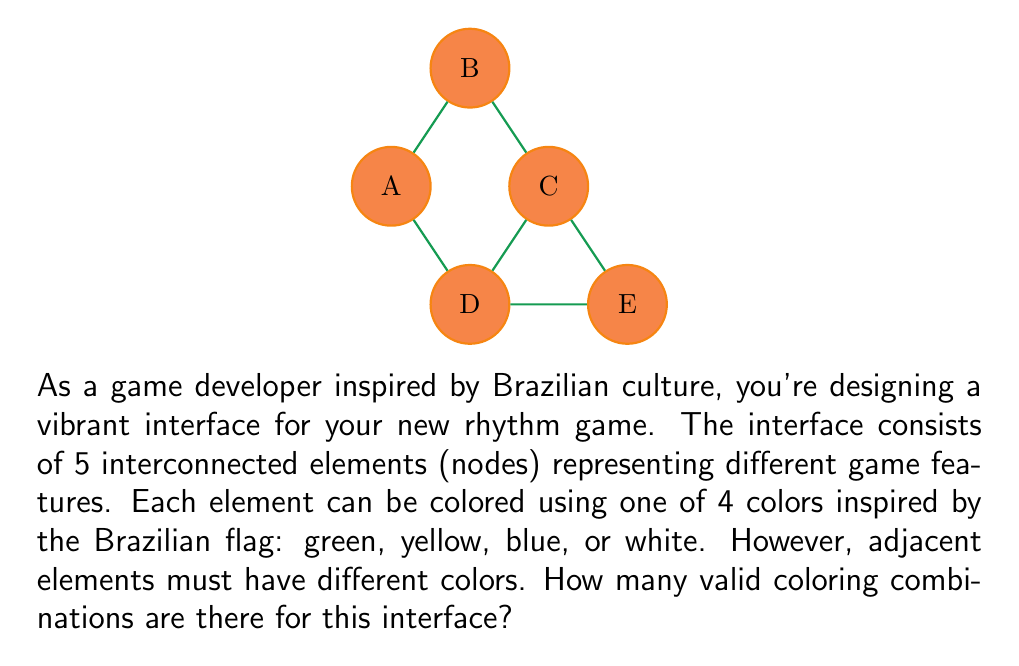Help me with this question. Let's approach this problem using graph coloring and the multiplication principle:

1) First, we need to recognize that this is a graph coloring problem where each node represents an interface element, and edges represent adjacency.

2) We'll use the chromatic polynomial to solve this. The chromatic polynomial $P(G,k)$ gives the number of ways to color a graph $G$ using $k$ colors.

3) For this graph, the chromatic polynomial is:

   $P(G,k) = k(k-1)^2(k-2)^2$

4) We can derive this by:
   - Coloring node A: $k$ ways
   - Coloring B and D (adjacent to A): $(k-1)$ ways each
   - Coloring C and E (adjacent to B or D): $(k-2)$ ways each

5) In our case, $k = 4$ (green, yellow, blue, white)

6) Substituting $k = 4$ into the chromatic polynomial:

   $P(G,4) = 4(4-1)^2(4-2)^2$
           $= 4 \cdot 3^2 \cdot 2^2$
           $= 4 \cdot 9 \cdot 4$
           $= 144$

Therefore, there are 144 valid coloring combinations for the game interface.
Answer: 144 